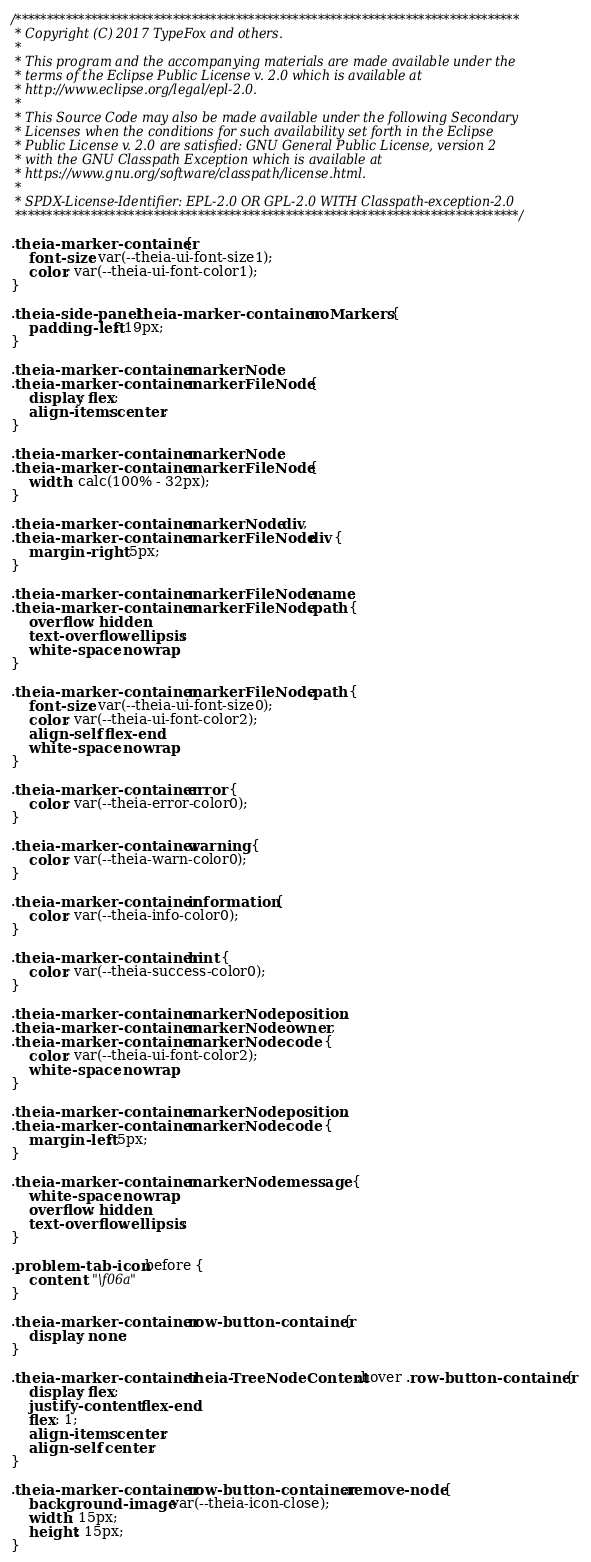Convert code to text. <code><loc_0><loc_0><loc_500><loc_500><_CSS_>/********************************************************************************
 * Copyright (C) 2017 TypeFox and others.
 *
 * This program and the accompanying materials are made available under the
 * terms of the Eclipse Public License v. 2.0 which is available at
 * http://www.eclipse.org/legal/epl-2.0.
 *
 * This Source Code may also be made available under the following Secondary
 * Licenses when the conditions for such availability set forth in the Eclipse
 * Public License v. 2.0 are satisfied: GNU General Public License, version 2
 * with the GNU Classpath Exception which is available at
 * https://www.gnu.org/software/classpath/license.html.
 *
 * SPDX-License-Identifier: EPL-2.0 OR GPL-2.0 WITH Classpath-exception-2.0
 ********************************************************************************/

.theia-marker-container {
    font-size: var(--theia-ui-font-size1);
    color: var(--theia-ui-font-color1);
}

.theia-side-panel .theia-marker-container .noMarkers {
    padding-left: 19px;
}

.theia-marker-container .markerNode,
.theia-marker-container .markerFileNode {
    display: flex;
    align-items: center;
}

.theia-marker-container .markerNode,
.theia-marker-container .markerFileNode {
    width: calc(100% - 32px);
}

.theia-marker-container .markerNode div,
.theia-marker-container .markerFileNode div {
    margin-right: 5px;
}

.theia-marker-container .markerFileNode .name,
.theia-marker-container .markerFileNode .path {
    overflow: hidden;
    text-overflow: ellipsis;
    white-space: nowrap;
}

.theia-marker-container .markerFileNode .path {
    font-size: var(--theia-ui-font-size0);
    color: var(--theia-ui-font-color2);
    align-self: flex-end;
    white-space: nowrap;
}

.theia-marker-container .error {
    color: var(--theia-error-color0);
}

.theia-marker-container .warning {
    color: var(--theia-warn-color0);
}

.theia-marker-container .information {
    color: var(--theia-info-color0);
}

.theia-marker-container .hint {
    color: var(--theia-success-color0);
}

.theia-marker-container .markerNode .position,
.theia-marker-container .markerNode .owner,
.theia-marker-container .markerNode .code {
    color: var(--theia-ui-font-color2);
    white-space: nowrap;
}

.theia-marker-container .markerNode .position,
.theia-marker-container .markerNode .code {
    margin-left: 5px;
}

.theia-marker-container .markerNode .message {
    white-space: nowrap;
    overflow: hidden;
    text-overflow: ellipsis;
}

.problem-tab-icon::before {
    content: "\f06a"
}

.theia-marker-container .row-button-container {
    display: none;
}

.theia-marker-container .theia-TreeNodeContent:hover .row-button-container {
    display: flex;
    justify-content: flex-end;
    flex: 1;
    align-items: center;
    align-self: center;
}

.theia-marker-container .row-button-container .remove-node {
    background-image: var(--theia-icon-close);
    width: 15px;
    height: 15px;
}
</code> 